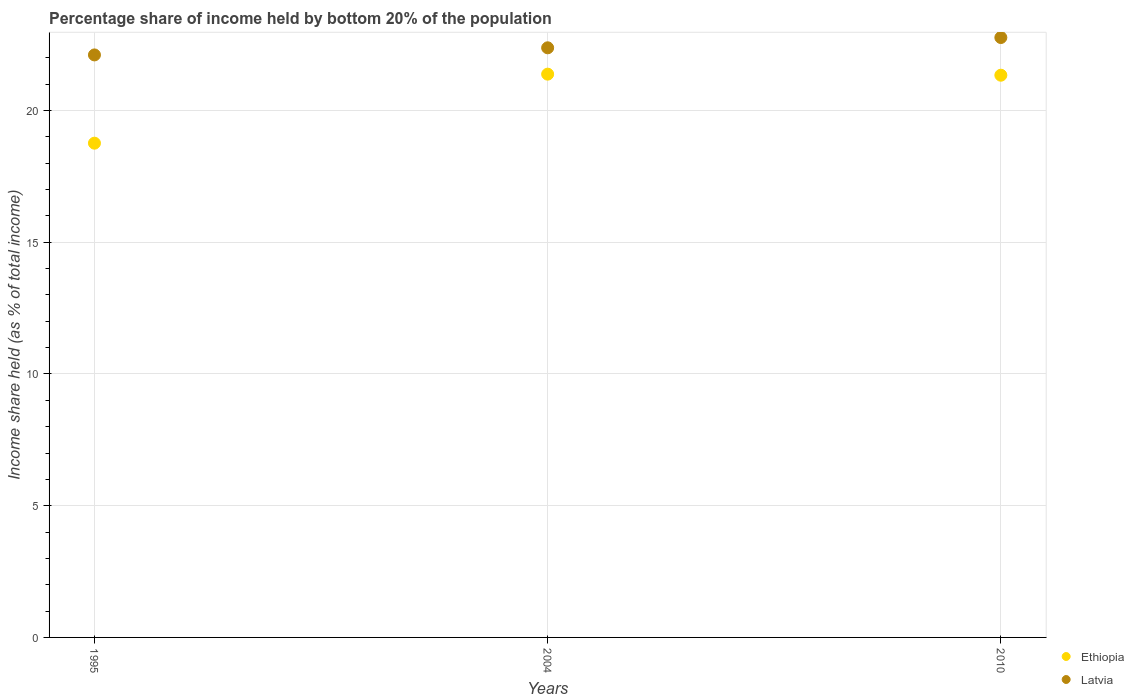How many different coloured dotlines are there?
Your answer should be very brief. 2. What is the share of income held by bottom 20% of the population in Latvia in 2010?
Give a very brief answer. 22.77. Across all years, what is the maximum share of income held by bottom 20% of the population in Ethiopia?
Your answer should be very brief. 21.38. Across all years, what is the minimum share of income held by bottom 20% of the population in Latvia?
Ensure brevity in your answer.  22.11. In which year was the share of income held by bottom 20% of the population in Latvia maximum?
Your answer should be compact. 2010. What is the total share of income held by bottom 20% of the population in Ethiopia in the graph?
Keep it short and to the point. 61.48. What is the difference between the share of income held by bottom 20% of the population in Ethiopia in 1995 and that in 2004?
Provide a succinct answer. -2.62. What is the difference between the share of income held by bottom 20% of the population in Latvia in 2004 and the share of income held by bottom 20% of the population in Ethiopia in 1995?
Your answer should be very brief. 3.62. What is the average share of income held by bottom 20% of the population in Ethiopia per year?
Keep it short and to the point. 20.49. In how many years, is the share of income held by bottom 20% of the population in Latvia greater than 16 %?
Provide a short and direct response. 3. What is the ratio of the share of income held by bottom 20% of the population in Ethiopia in 1995 to that in 2004?
Give a very brief answer. 0.88. Is the share of income held by bottom 20% of the population in Ethiopia in 1995 less than that in 2004?
Offer a very short reply. Yes. Is the difference between the share of income held by bottom 20% of the population in Ethiopia in 1995 and 2010 greater than the difference between the share of income held by bottom 20% of the population in Latvia in 1995 and 2010?
Provide a succinct answer. No. What is the difference between the highest and the second highest share of income held by bottom 20% of the population in Ethiopia?
Your answer should be very brief. 0.04. What is the difference between the highest and the lowest share of income held by bottom 20% of the population in Ethiopia?
Provide a succinct answer. 2.62. In how many years, is the share of income held by bottom 20% of the population in Latvia greater than the average share of income held by bottom 20% of the population in Latvia taken over all years?
Your answer should be very brief. 1. Is the sum of the share of income held by bottom 20% of the population in Latvia in 1995 and 2004 greater than the maximum share of income held by bottom 20% of the population in Ethiopia across all years?
Offer a very short reply. Yes. Is the share of income held by bottom 20% of the population in Latvia strictly greater than the share of income held by bottom 20% of the population in Ethiopia over the years?
Ensure brevity in your answer.  Yes. How many dotlines are there?
Provide a short and direct response. 2. How many years are there in the graph?
Make the answer very short. 3. Are the values on the major ticks of Y-axis written in scientific E-notation?
Your answer should be compact. No. Does the graph contain any zero values?
Offer a terse response. No. Does the graph contain grids?
Give a very brief answer. Yes. How many legend labels are there?
Your answer should be compact. 2. How are the legend labels stacked?
Your answer should be compact. Vertical. What is the title of the graph?
Provide a succinct answer. Percentage share of income held by bottom 20% of the population. Does "Bulgaria" appear as one of the legend labels in the graph?
Make the answer very short. No. What is the label or title of the X-axis?
Keep it short and to the point. Years. What is the label or title of the Y-axis?
Offer a terse response. Income share held (as % of total income). What is the Income share held (as % of total income) in Ethiopia in 1995?
Make the answer very short. 18.76. What is the Income share held (as % of total income) of Latvia in 1995?
Keep it short and to the point. 22.11. What is the Income share held (as % of total income) in Ethiopia in 2004?
Keep it short and to the point. 21.38. What is the Income share held (as % of total income) of Latvia in 2004?
Offer a very short reply. 22.38. What is the Income share held (as % of total income) in Ethiopia in 2010?
Provide a short and direct response. 21.34. What is the Income share held (as % of total income) of Latvia in 2010?
Your response must be concise. 22.77. Across all years, what is the maximum Income share held (as % of total income) in Ethiopia?
Your answer should be very brief. 21.38. Across all years, what is the maximum Income share held (as % of total income) in Latvia?
Your answer should be very brief. 22.77. Across all years, what is the minimum Income share held (as % of total income) in Ethiopia?
Keep it short and to the point. 18.76. Across all years, what is the minimum Income share held (as % of total income) of Latvia?
Provide a succinct answer. 22.11. What is the total Income share held (as % of total income) of Ethiopia in the graph?
Ensure brevity in your answer.  61.48. What is the total Income share held (as % of total income) in Latvia in the graph?
Provide a short and direct response. 67.26. What is the difference between the Income share held (as % of total income) of Ethiopia in 1995 and that in 2004?
Keep it short and to the point. -2.62. What is the difference between the Income share held (as % of total income) of Latvia in 1995 and that in 2004?
Give a very brief answer. -0.27. What is the difference between the Income share held (as % of total income) in Ethiopia in 1995 and that in 2010?
Your answer should be compact. -2.58. What is the difference between the Income share held (as % of total income) in Latvia in 1995 and that in 2010?
Give a very brief answer. -0.66. What is the difference between the Income share held (as % of total income) in Ethiopia in 2004 and that in 2010?
Keep it short and to the point. 0.04. What is the difference between the Income share held (as % of total income) of Latvia in 2004 and that in 2010?
Offer a terse response. -0.39. What is the difference between the Income share held (as % of total income) of Ethiopia in 1995 and the Income share held (as % of total income) of Latvia in 2004?
Make the answer very short. -3.62. What is the difference between the Income share held (as % of total income) in Ethiopia in 1995 and the Income share held (as % of total income) in Latvia in 2010?
Provide a succinct answer. -4.01. What is the difference between the Income share held (as % of total income) of Ethiopia in 2004 and the Income share held (as % of total income) of Latvia in 2010?
Your answer should be very brief. -1.39. What is the average Income share held (as % of total income) in Ethiopia per year?
Keep it short and to the point. 20.49. What is the average Income share held (as % of total income) in Latvia per year?
Your answer should be very brief. 22.42. In the year 1995, what is the difference between the Income share held (as % of total income) in Ethiopia and Income share held (as % of total income) in Latvia?
Your answer should be very brief. -3.35. In the year 2010, what is the difference between the Income share held (as % of total income) of Ethiopia and Income share held (as % of total income) of Latvia?
Provide a short and direct response. -1.43. What is the ratio of the Income share held (as % of total income) of Ethiopia in 1995 to that in 2004?
Give a very brief answer. 0.88. What is the ratio of the Income share held (as % of total income) in Latvia in 1995 to that in 2004?
Make the answer very short. 0.99. What is the ratio of the Income share held (as % of total income) of Ethiopia in 1995 to that in 2010?
Your response must be concise. 0.88. What is the ratio of the Income share held (as % of total income) in Ethiopia in 2004 to that in 2010?
Your answer should be very brief. 1. What is the ratio of the Income share held (as % of total income) of Latvia in 2004 to that in 2010?
Ensure brevity in your answer.  0.98. What is the difference between the highest and the second highest Income share held (as % of total income) in Ethiopia?
Make the answer very short. 0.04. What is the difference between the highest and the second highest Income share held (as % of total income) of Latvia?
Make the answer very short. 0.39. What is the difference between the highest and the lowest Income share held (as % of total income) in Ethiopia?
Your answer should be very brief. 2.62. What is the difference between the highest and the lowest Income share held (as % of total income) of Latvia?
Make the answer very short. 0.66. 